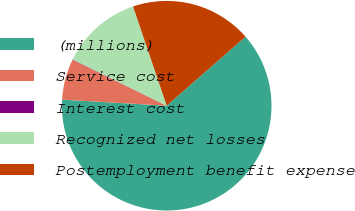Convert chart to OTSL. <chart><loc_0><loc_0><loc_500><loc_500><pie_chart><fcel>(millions)<fcel>Service cost<fcel>Interest cost<fcel>Recognized net losses<fcel>Postemployment benefit expense<nl><fcel>62.37%<fcel>6.29%<fcel>0.06%<fcel>12.52%<fcel>18.75%<nl></chart> 